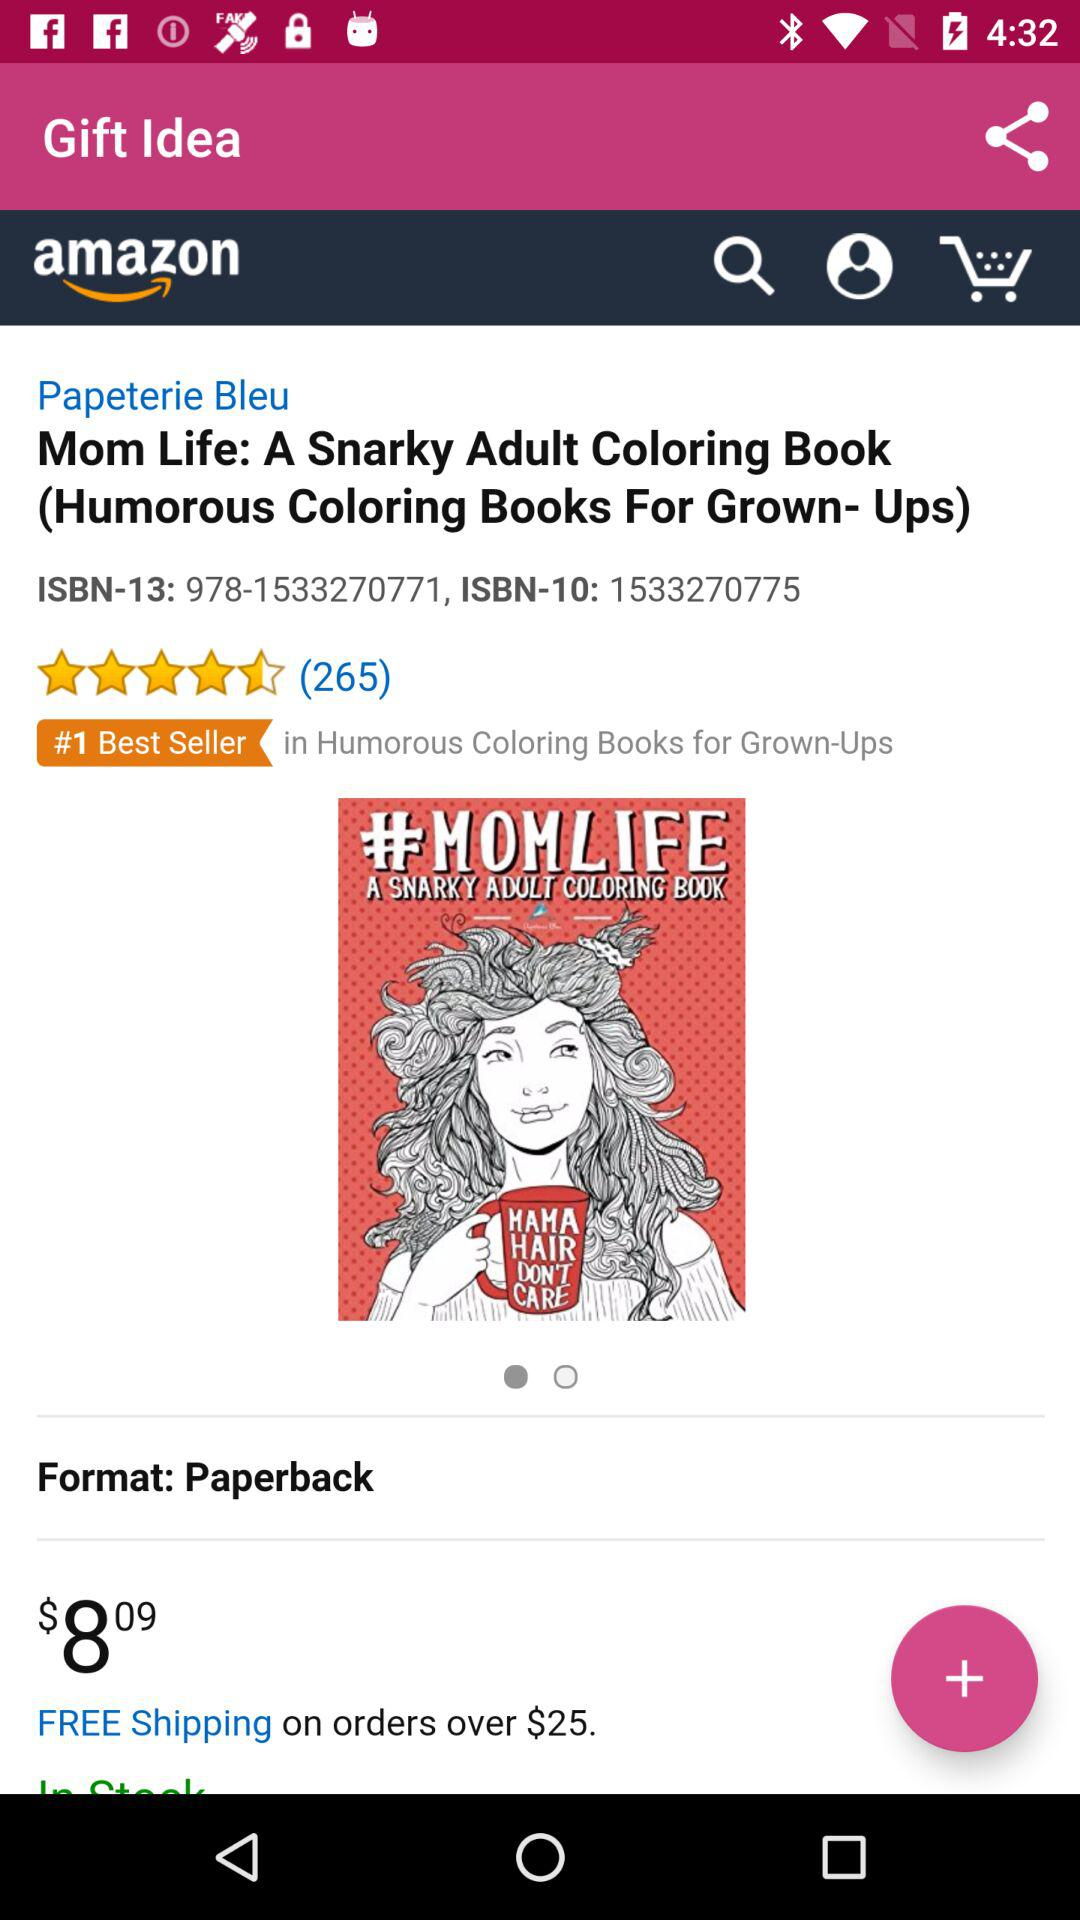How many reviews are there for "Mom Life: A Snarky Adult Coloring Book"? There are 265 reviews for "Mom Life: A Snarky Adult Coloring Book". 